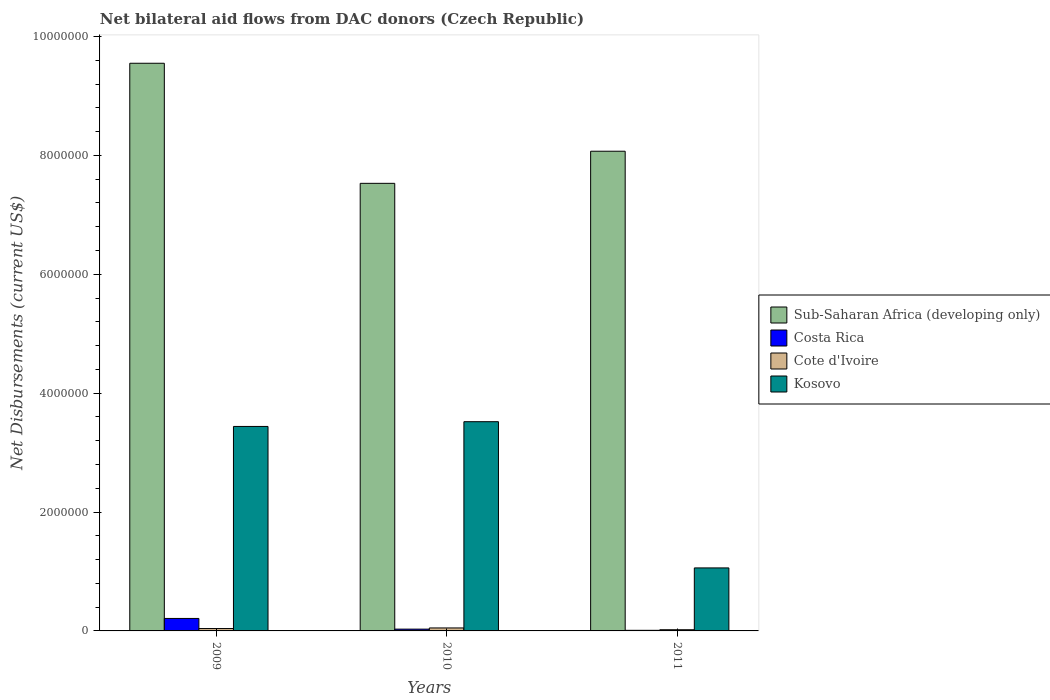What is the net bilateral aid flows in Sub-Saharan Africa (developing only) in 2009?
Your response must be concise. 9.55e+06. Across all years, what is the maximum net bilateral aid flows in Cote d'Ivoire?
Ensure brevity in your answer.  5.00e+04. Across all years, what is the minimum net bilateral aid flows in Cote d'Ivoire?
Offer a terse response. 2.00e+04. What is the total net bilateral aid flows in Cote d'Ivoire in the graph?
Ensure brevity in your answer.  1.10e+05. What is the difference between the net bilateral aid flows in Sub-Saharan Africa (developing only) in 2009 and that in 2010?
Give a very brief answer. 2.02e+06. What is the difference between the net bilateral aid flows in Cote d'Ivoire in 2011 and the net bilateral aid flows in Kosovo in 2009?
Make the answer very short. -3.42e+06. What is the average net bilateral aid flows in Kosovo per year?
Give a very brief answer. 2.67e+06. In the year 2011, what is the difference between the net bilateral aid flows in Sub-Saharan Africa (developing only) and net bilateral aid flows in Costa Rica?
Provide a short and direct response. 8.06e+06. Is the net bilateral aid flows in Kosovo in 2009 less than that in 2010?
Offer a very short reply. Yes. Is the difference between the net bilateral aid flows in Sub-Saharan Africa (developing only) in 2010 and 2011 greater than the difference between the net bilateral aid flows in Costa Rica in 2010 and 2011?
Your answer should be compact. No. What is the difference between the highest and the lowest net bilateral aid flows in Sub-Saharan Africa (developing only)?
Ensure brevity in your answer.  2.02e+06. In how many years, is the net bilateral aid flows in Kosovo greater than the average net bilateral aid flows in Kosovo taken over all years?
Keep it short and to the point. 2. What does the 4th bar from the left in 2010 represents?
Give a very brief answer. Kosovo. Is it the case that in every year, the sum of the net bilateral aid flows in Kosovo and net bilateral aid flows in Costa Rica is greater than the net bilateral aid flows in Sub-Saharan Africa (developing only)?
Give a very brief answer. No. Are all the bars in the graph horizontal?
Keep it short and to the point. No. Are the values on the major ticks of Y-axis written in scientific E-notation?
Provide a succinct answer. No. Does the graph contain any zero values?
Offer a terse response. No. How many legend labels are there?
Ensure brevity in your answer.  4. What is the title of the graph?
Keep it short and to the point. Net bilateral aid flows from DAC donors (Czech Republic). Does "Tunisia" appear as one of the legend labels in the graph?
Your response must be concise. No. What is the label or title of the X-axis?
Keep it short and to the point. Years. What is the label or title of the Y-axis?
Provide a short and direct response. Net Disbursements (current US$). What is the Net Disbursements (current US$) in Sub-Saharan Africa (developing only) in 2009?
Ensure brevity in your answer.  9.55e+06. What is the Net Disbursements (current US$) of Costa Rica in 2009?
Provide a succinct answer. 2.10e+05. What is the Net Disbursements (current US$) in Kosovo in 2009?
Make the answer very short. 3.44e+06. What is the Net Disbursements (current US$) in Sub-Saharan Africa (developing only) in 2010?
Give a very brief answer. 7.53e+06. What is the Net Disbursements (current US$) of Costa Rica in 2010?
Your response must be concise. 3.00e+04. What is the Net Disbursements (current US$) of Kosovo in 2010?
Give a very brief answer. 3.52e+06. What is the Net Disbursements (current US$) in Sub-Saharan Africa (developing only) in 2011?
Your answer should be very brief. 8.07e+06. What is the Net Disbursements (current US$) of Costa Rica in 2011?
Keep it short and to the point. 10000. What is the Net Disbursements (current US$) of Cote d'Ivoire in 2011?
Keep it short and to the point. 2.00e+04. What is the Net Disbursements (current US$) in Kosovo in 2011?
Your answer should be compact. 1.06e+06. Across all years, what is the maximum Net Disbursements (current US$) of Sub-Saharan Africa (developing only)?
Provide a succinct answer. 9.55e+06. Across all years, what is the maximum Net Disbursements (current US$) in Cote d'Ivoire?
Provide a short and direct response. 5.00e+04. Across all years, what is the maximum Net Disbursements (current US$) in Kosovo?
Your answer should be compact. 3.52e+06. Across all years, what is the minimum Net Disbursements (current US$) in Sub-Saharan Africa (developing only)?
Provide a succinct answer. 7.53e+06. Across all years, what is the minimum Net Disbursements (current US$) of Kosovo?
Offer a terse response. 1.06e+06. What is the total Net Disbursements (current US$) in Sub-Saharan Africa (developing only) in the graph?
Keep it short and to the point. 2.52e+07. What is the total Net Disbursements (current US$) of Kosovo in the graph?
Your answer should be compact. 8.02e+06. What is the difference between the Net Disbursements (current US$) in Sub-Saharan Africa (developing only) in 2009 and that in 2010?
Your response must be concise. 2.02e+06. What is the difference between the Net Disbursements (current US$) in Costa Rica in 2009 and that in 2010?
Your response must be concise. 1.80e+05. What is the difference between the Net Disbursements (current US$) in Cote d'Ivoire in 2009 and that in 2010?
Your answer should be compact. -10000. What is the difference between the Net Disbursements (current US$) in Sub-Saharan Africa (developing only) in 2009 and that in 2011?
Your response must be concise. 1.48e+06. What is the difference between the Net Disbursements (current US$) of Kosovo in 2009 and that in 2011?
Provide a succinct answer. 2.38e+06. What is the difference between the Net Disbursements (current US$) in Sub-Saharan Africa (developing only) in 2010 and that in 2011?
Ensure brevity in your answer.  -5.40e+05. What is the difference between the Net Disbursements (current US$) of Costa Rica in 2010 and that in 2011?
Give a very brief answer. 2.00e+04. What is the difference between the Net Disbursements (current US$) of Cote d'Ivoire in 2010 and that in 2011?
Make the answer very short. 3.00e+04. What is the difference between the Net Disbursements (current US$) of Kosovo in 2010 and that in 2011?
Your answer should be compact. 2.46e+06. What is the difference between the Net Disbursements (current US$) of Sub-Saharan Africa (developing only) in 2009 and the Net Disbursements (current US$) of Costa Rica in 2010?
Give a very brief answer. 9.52e+06. What is the difference between the Net Disbursements (current US$) of Sub-Saharan Africa (developing only) in 2009 and the Net Disbursements (current US$) of Cote d'Ivoire in 2010?
Make the answer very short. 9.50e+06. What is the difference between the Net Disbursements (current US$) in Sub-Saharan Africa (developing only) in 2009 and the Net Disbursements (current US$) in Kosovo in 2010?
Offer a very short reply. 6.03e+06. What is the difference between the Net Disbursements (current US$) of Costa Rica in 2009 and the Net Disbursements (current US$) of Cote d'Ivoire in 2010?
Your answer should be very brief. 1.60e+05. What is the difference between the Net Disbursements (current US$) of Costa Rica in 2009 and the Net Disbursements (current US$) of Kosovo in 2010?
Offer a very short reply. -3.31e+06. What is the difference between the Net Disbursements (current US$) of Cote d'Ivoire in 2009 and the Net Disbursements (current US$) of Kosovo in 2010?
Your response must be concise. -3.48e+06. What is the difference between the Net Disbursements (current US$) of Sub-Saharan Africa (developing only) in 2009 and the Net Disbursements (current US$) of Costa Rica in 2011?
Give a very brief answer. 9.54e+06. What is the difference between the Net Disbursements (current US$) in Sub-Saharan Africa (developing only) in 2009 and the Net Disbursements (current US$) in Cote d'Ivoire in 2011?
Provide a short and direct response. 9.53e+06. What is the difference between the Net Disbursements (current US$) in Sub-Saharan Africa (developing only) in 2009 and the Net Disbursements (current US$) in Kosovo in 2011?
Make the answer very short. 8.49e+06. What is the difference between the Net Disbursements (current US$) of Costa Rica in 2009 and the Net Disbursements (current US$) of Cote d'Ivoire in 2011?
Your answer should be very brief. 1.90e+05. What is the difference between the Net Disbursements (current US$) of Costa Rica in 2009 and the Net Disbursements (current US$) of Kosovo in 2011?
Your answer should be compact. -8.50e+05. What is the difference between the Net Disbursements (current US$) in Cote d'Ivoire in 2009 and the Net Disbursements (current US$) in Kosovo in 2011?
Provide a succinct answer. -1.02e+06. What is the difference between the Net Disbursements (current US$) of Sub-Saharan Africa (developing only) in 2010 and the Net Disbursements (current US$) of Costa Rica in 2011?
Provide a short and direct response. 7.52e+06. What is the difference between the Net Disbursements (current US$) of Sub-Saharan Africa (developing only) in 2010 and the Net Disbursements (current US$) of Cote d'Ivoire in 2011?
Your answer should be very brief. 7.51e+06. What is the difference between the Net Disbursements (current US$) in Sub-Saharan Africa (developing only) in 2010 and the Net Disbursements (current US$) in Kosovo in 2011?
Offer a very short reply. 6.47e+06. What is the difference between the Net Disbursements (current US$) of Costa Rica in 2010 and the Net Disbursements (current US$) of Kosovo in 2011?
Your response must be concise. -1.03e+06. What is the difference between the Net Disbursements (current US$) of Cote d'Ivoire in 2010 and the Net Disbursements (current US$) of Kosovo in 2011?
Your answer should be compact. -1.01e+06. What is the average Net Disbursements (current US$) in Sub-Saharan Africa (developing only) per year?
Keep it short and to the point. 8.38e+06. What is the average Net Disbursements (current US$) in Costa Rica per year?
Offer a very short reply. 8.33e+04. What is the average Net Disbursements (current US$) in Cote d'Ivoire per year?
Keep it short and to the point. 3.67e+04. What is the average Net Disbursements (current US$) of Kosovo per year?
Keep it short and to the point. 2.67e+06. In the year 2009, what is the difference between the Net Disbursements (current US$) of Sub-Saharan Africa (developing only) and Net Disbursements (current US$) of Costa Rica?
Provide a succinct answer. 9.34e+06. In the year 2009, what is the difference between the Net Disbursements (current US$) in Sub-Saharan Africa (developing only) and Net Disbursements (current US$) in Cote d'Ivoire?
Offer a terse response. 9.51e+06. In the year 2009, what is the difference between the Net Disbursements (current US$) in Sub-Saharan Africa (developing only) and Net Disbursements (current US$) in Kosovo?
Make the answer very short. 6.11e+06. In the year 2009, what is the difference between the Net Disbursements (current US$) of Costa Rica and Net Disbursements (current US$) of Cote d'Ivoire?
Provide a short and direct response. 1.70e+05. In the year 2009, what is the difference between the Net Disbursements (current US$) of Costa Rica and Net Disbursements (current US$) of Kosovo?
Offer a terse response. -3.23e+06. In the year 2009, what is the difference between the Net Disbursements (current US$) in Cote d'Ivoire and Net Disbursements (current US$) in Kosovo?
Your response must be concise. -3.40e+06. In the year 2010, what is the difference between the Net Disbursements (current US$) of Sub-Saharan Africa (developing only) and Net Disbursements (current US$) of Costa Rica?
Ensure brevity in your answer.  7.50e+06. In the year 2010, what is the difference between the Net Disbursements (current US$) of Sub-Saharan Africa (developing only) and Net Disbursements (current US$) of Cote d'Ivoire?
Offer a very short reply. 7.48e+06. In the year 2010, what is the difference between the Net Disbursements (current US$) in Sub-Saharan Africa (developing only) and Net Disbursements (current US$) in Kosovo?
Offer a terse response. 4.01e+06. In the year 2010, what is the difference between the Net Disbursements (current US$) in Costa Rica and Net Disbursements (current US$) in Kosovo?
Keep it short and to the point. -3.49e+06. In the year 2010, what is the difference between the Net Disbursements (current US$) of Cote d'Ivoire and Net Disbursements (current US$) of Kosovo?
Give a very brief answer. -3.47e+06. In the year 2011, what is the difference between the Net Disbursements (current US$) in Sub-Saharan Africa (developing only) and Net Disbursements (current US$) in Costa Rica?
Your response must be concise. 8.06e+06. In the year 2011, what is the difference between the Net Disbursements (current US$) in Sub-Saharan Africa (developing only) and Net Disbursements (current US$) in Cote d'Ivoire?
Provide a short and direct response. 8.05e+06. In the year 2011, what is the difference between the Net Disbursements (current US$) of Sub-Saharan Africa (developing only) and Net Disbursements (current US$) of Kosovo?
Your answer should be very brief. 7.01e+06. In the year 2011, what is the difference between the Net Disbursements (current US$) of Costa Rica and Net Disbursements (current US$) of Kosovo?
Offer a very short reply. -1.05e+06. In the year 2011, what is the difference between the Net Disbursements (current US$) of Cote d'Ivoire and Net Disbursements (current US$) of Kosovo?
Your response must be concise. -1.04e+06. What is the ratio of the Net Disbursements (current US$) of Sub-Saharan Africa (developing only) in 2009 to that in 2010?
Your response must be concise. 1.27. What is the ratio of the Net Disbursements (current US$) of Costa Rica in 2009 to that in 2010?
Give a very brief answer. 7. What is the ratio of the Net Disbursements (current US$) of Kosovo in 2009 to that in 2010?
Your response must be concise. 0.98. What is the ratio of the Net Disbursements (current US$) of Sub-Saharan Africa (developing only) in 2009 to that in 2011?
Make the answer very short. 1.18. What is the ratio of the Net Disbursements (current US$) in Costa Rica in 2009 to that in 2011?
Make the answer very short. 21. What is the ratio of the Net Disbursements (current US$) in Kosovo in 2009 to that in 2011?
Offer a very short reply. 3.25. What is the ratio of the Net Disbursements (current US$) in Sub-Saharan Africa (developing only) in 2010 to that in 2011?
Make the answer very short. 0.93. What is the ratio of the Net Disbursements (current US$) in Costa Rica in 2010 to that in 2011?
Provide a succinct answer. 3. What is the ratio of the Net Disbursements (current US$) in Kosovo in 2010 to that in 2011?
Your answer should be compact. 3.32. What is the difference between the highest and the second highest Net Disbursements (current US$) in Sub-Saharan Africa (developing only)?
Offer a very short reply. 1.48e+06. What is the difference between the highest and the second highest Net Disbursements (current US$) of Costa Rica?
Your answer should be compact. 1.80e+05. What is the difference between the highest and the second highest Net Disbursements (current US$) of Cote d'Ivoire?
Your answer should be very brief. 10000. What is the difference between the highest and the second highest Net Disbursements (current US$) in Kosovo?
Offer a terse response. 8.00e+04. What is the difference between the highest and the lowest Net Disbursements (current US$) in Sub-Saharan Africa (developing only)?
Offer a very short reply. 2.02e+06. What is the difference between the highest and the lowest Net Disbursements (current US$) in Costa Rica?
Your answer should be compact. 2.00e+05. What is the difference between the highest and the lowest Net Disbursements (current US$) of Kosovo?
Provide a succinct answer. 2.46e+06. 